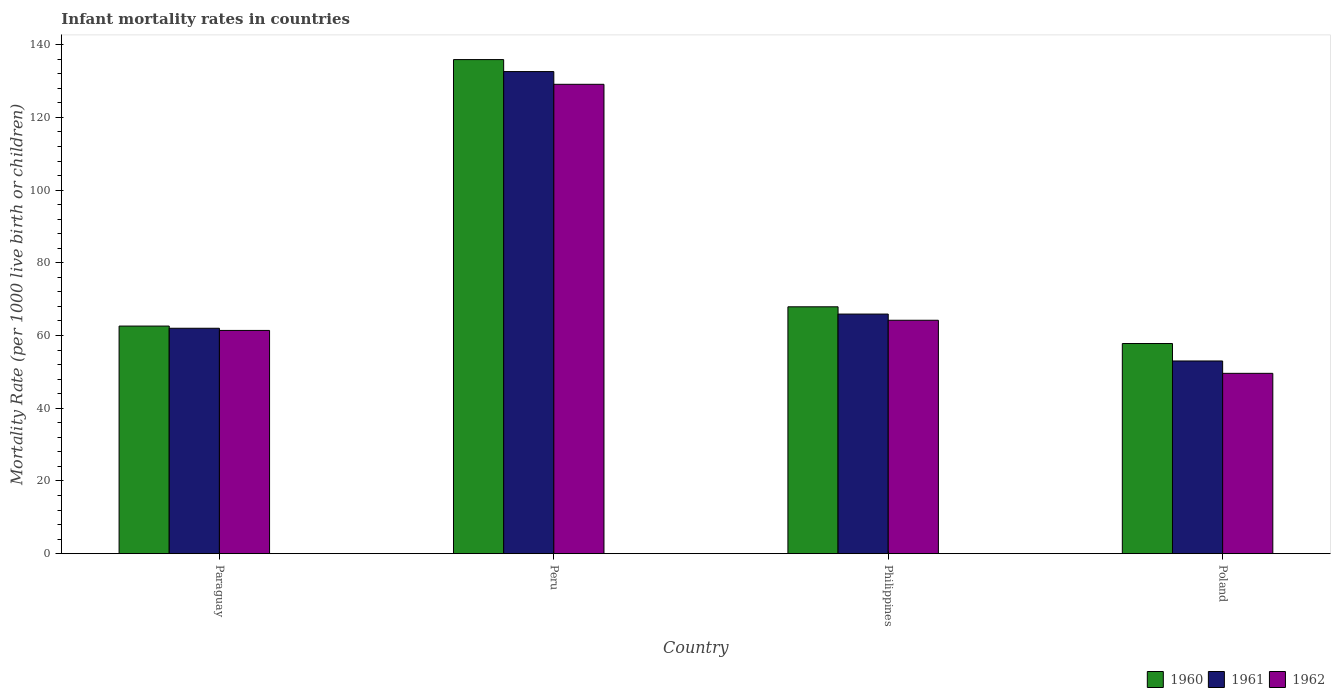How many bars are there on the 2nd tick from the left?
Give a very brief answer. 3. What is the label of the 1st group of bars from the left?
Your answer should be very brief. Paraguay. In how many cases, is the number of bars for a given country not equal to the number of legend labels?
Keep it short and to the point. 0. What is the infant mortality rate in 1961 in Poland?
Offer a terse response. 53. Across all countries, what is the maximum infant mortality rate in 1962?
Keep it short and to the point. 129.1. Across all countries, what is the minimum infant mortality rate in 1960?
Offer a terse response. 57.8. What is the total infant mortality rate in 1962 in the graph?
Your response must be concise. 304.3. What is the difference between the infant mortality rate in 1962 in Peru and the infant mortality rate in 1960 in Philippines?
Give a very brief answer. 61.2. What is the average infant mortality rate in 1962 per country?
Offer a very short reply. 76.08. What is the difference between the infant mortality rate of/in 1962 and infant mortality rate of/in 1961 in Peru?
Ensure brevity in your answer.  -3.5. What is the ratio of the infant mortality rate in 1960 in Peru to that in Philippines?
Make the answer very short. 2. Is the infant mortality rate in 1961 in Paraguay less than that in Poland?
Give a very brief answer. No. What is the difference between the highest and the second highest infant mortality rate in 1960?
Make the answer very short. 5.3. What is the difference between the highest and the lowest infant mortality rate in 1960?
Your answer should be very brief. 78.1. What does the 1st bar from the left in Poland represents?
Give a very brief answer. 1960. What does the 2nd bar from the right in Philippines represents?
Give a very brief answer. 1961. Is it the case that in every country, the sum of the infant mortality rate in 1962 and infant mortality rate in 1960 is greater than the infant mortality rate in 1961?
Offer a very short reply. Yes. How many bars are there?
Provide a short and direct response. 12. Are all the bars in the graph horizontal?
Give a very brief answer. No. What is the difference between two consecutive major ticks on the Y-axis?
Your response must be concise. 20. Does the graph contain any zero values?
Offer a terse response. No. How many legend labels are there?
Your response must be concise. 3. How are the legend labels stacked?
Provide a short and direct response. Horizontal. What is the title of the graph?
Offer a very short reply. Infant mortality rates in countries. Does "1984" appear as one of the legend labels in the graph?
Your answer should be very brief. No. What is the label or title of the X-axis?
Keep it short and to the point. Country. What is the label or title of the Y-axis?
Offer a terse response. Mortality Rate (per 1000 live birth or children). What is the Mortality Rate (per 1000 live birth or children) of 1960 in Paraguay?
Provide a short and direct response. 62.6. What is the Mortality Rate (per 1000 live birth or children) in 1961 in Paraguay?
Provide a succinct answer. 62. What is the Mortality Rate (per 1000 live birth or children) in 1962 in Paraguay?
Keep it short and to the point. 61.4. What is the Mortality Rate (per 1000 live birth or children) of 1960 in Peru?
Your response must be concise. 135.9. What is the Mortality Rate (per 1000 live birth or children) in 1961 in Peru?
Offer a very short reply. 132.6. What is the Mortality Rate (per 1000 live birth or children) in 1962 in Peru?
Provide a short and direct response. 129.1. What is the Mortality Rate (per 1000 live birth or children) of 1960 in Philippines?
Your answer should be very brief. 67.9. What is the Mortality Rate (per 1000 live birth or children) of 1961 in Philippines?
Make the answer very short. 65.9. What is the Mortality Rate (per 1000 live birth or children) of 1962 in Philippines?
Offer a very short reply. 64.2. What is the Mortality Rate (per 1000 live birth or children) of 1960 in Poland?
Your response must be concise. 57.8. What is the Mortality Rate (per 1000 live birth or children) in 1961 in Poland?
Provide a succinct answer. 53. What is the Mortality Rate (per 1000 live birth or children) of 1962 in Poland?
Your response must be concise. 49.6. Across all countries, what is the maximum Mortality Rate (per 1000 live birth or children) in 1960?
Your answer should be very brief. 135.9. Across all countries, what is the maximum Mortality Rate (per 1000 live birth or children) in 1961?
Offer a terse response. 132.6. Across all countries, what is the maximum Mortality Rate (per 1000 live birth or children) of 1962?
Your response must be concise. 129.1. Across all countries, what is the minimum Mortality Rate (per 1000 live birth or children) of 1960?
Provide a succinct answer. 57.8. Across all countries, what is the minimum Mortality Rate (per 1000 live birth or children) in 1961?
Your answer should be very brief. 53. Across all countries, what is the minimum Mortality Rate (per 1000 live birth or children) in 1962?
Offer a terse response. 49.6. What is the total Mortality Rate (per 1000 live birth or children) in 1960 in the graph?
Your answer should be very brief. 324.2. What is the total Mortality Rate (per 1000 live birth or children) of 1961 in the graph?
Ensure brevity in your answer.  313.5. What is the total Mortality Rate (per 1000 live birth or children) in 1962 in the graph?
Your response must be concise. 304.3. What is the difference between the Mortality Rate (per 1000 live birth or children) in 1960 in Paraguay and that in Peru?
Keep it short and to the point. -73.3. What is the difference between the Mortality Rate (per 1000 live birth or children) of 1961 in Paraguay and that in Peru?
Provide a succinct answer. -70.6. What is the difference between the Mortality Rate (per 1000 live birth or children) in 1962 in Paraguay and that in Peru?
Provide a succinct answer. -67.7. What is the difference between the Mortality Rate (per 1000 live birth or children) of 1961 in Paraguay and that in Philippines?
Give a very brief answer. -3.9. What is the difference between the Mortality Rate (per 1000 live birth or children) of 1962 in Paraguay and that in Philippines?
Your answer should be very brief. -2.8. What is the difference between the Mortality Rate (per 1000 live birth or children) in 1960 in Paraguay and that in Poland?
Ensure brevity in your answer.  4.8. What is the difference between the Mortality Rate (per 1000 live birth or children) in 1960 in Peru and that in Philippines?
Offer a terse response. 68. What is the difference between the Mortality Rate (per 1000 live birth or children) of 1961 in Peru and that in Philippines?
Your response must be concise. 66.7. What is the difference between the Mortality Rate (per 1000 live birth or children) of 1962 in Peru and that in Philippines?
Keep it short and to the point. 64.9. What is the difference between the Mortality Rate (per 1000 live birth or children) of 1960 in Peru and that in Poland?
Your answer should be very brief. 78.1. What is the difference between the Mortality Rate (per 1000 live birth or children) of 1961 in Peru and that in Poland?
Offer a terse response. 79.6. What is the difference between the Mortality Rate (per 1000 live birth or children) in 1962 in Peru and that in Poland?
Make the answer very short. 79.5. What is the difference between the Mortality Rate (per 1000 live birth or children) in 1961 in Philippines and that in Poland?
Keep it short and to the point. 12.9. What is the difference between the Mortality Rate (per 1000 live birth or children) in 1960 in Paraguay and the Mortality Rate (per 1000 live birth or children) in 1961 in Peru?
Make the answer very short. -70. What is the difference between the Mortality Rate (per 1000 live birth or children) of 1960 in Paraguay and the Mortality Rate (per 1000 live birth or children) of 1962 in Peru?
Keep it short and to the point. -66.5. What is the difference between the Mortality Rate (per 1000 live birth or children) of 1961 in Paraguay and the Mortality Rate (per 1000 live birth or children) of 1962 in Peru?
Make the answer very short. -67.1. What is the difference between the Mortality Rate (per 1000 live birth or children) of 1960 in Paraguay and the Mortality Rate (per 1000 live birth or children) of 1962 in Philippines?
Give a very brief answer. -1.6. What is the difference between the Mortality Rate (per 1000 live birth or children) of 1960 in Paraguay and the Mortality Rate (per 1000 live birth or children) of 1961 in Poland?
Give a very brief answer. 9.6. What is the difference between the Mortality Rate (per 1000 live birth or children) in 1960 in Peru and the Mortality Rate (per 1000 live birth or children) in 1961 in Philippines?
Provide a succinct answer. 70. What is the difference between the Mortality Rate (per 1000 live birth or children) of 1960 in Peru and the Mortality Rate (per 1000 live birth or children) of 1962 in Philippines?
Your answer should be compact. 71.7. What is the difference between the Mortality Rate (per 1000 live birth or children) of 1961 in Peru and the Mortality Rate (per 1000 live birth or children) of 1962 in Philippines?
Your response must be concise. 68.4. What is the difference between the Mortality Rate (per 1000 live birth or children) in 1960 in Peru and the Mortality Rate (per 1000 live birth or children) in 1961 in Poland?
Your answer should be compact. 82.9. What is the difference between the Mortality Rate (per 1000 live birth or children) of 1960 in Peru and the Mortality Rate (per 1000 live birth or children) of 1962 in Poland?
Provide a succinct answer. 86.3. What is the difference between the Mortality Rate (per 1000 live birth or children) of 1960 in Philippines and the Mortality Rate (per 1000 live birth or children) of 1962 in Poland?
Provide a succinct answer. 18.3. What is the difference between the Mortality Rate (per 1000 live birth or children) of 1961 in Philippines and the Mortality Rate (per 1000 live birth or children) of 1962 in Poland?
Your answer should be compact. 16.3. What is the average Mortality Rate (per 1000 live birth or children) of 1960 per country?
Provide a succinct answer. 81.05. What is the average Mortality Rate (per 1000 live birth or children) in 1961 per country?
Ensure brevity in your answer.  78.38. What is the average Mortality Rate (per 1000 live birth or children) in 1962 per country?
Provide a succinct answer. 76.08. What is the difference between the Mortality Rate (per 1000 live birth or children) in 1960 and Mortality Rate (per 1000 live birth or children) in 1962 in Paraguay?
Offer a terse response. 1.2. What is the difference between the Mortality Rate (per 1000 live birth or children) of 1961 and Mortality Rate (per 1000 live birth or children) of 1962 in Peru?
Offer a terse response. 3.5. What is the difference between the Mortality Rate (per 1000 live birth or children) in 1960 and Mortality Rate (per 1000 live birth or children) in 1961 in Philippines?
Provide a short and direct response. 2. What is the difference between the Mortality Rate (per 1000 live birth or children) of 1961 and Mortality Rate (per 1000 live birth or children) of 1962 in Philippines?
Your response must be concise. 1.7. What is the difference between the Mortality Rate (per 1000 live birth or children) of 1960 and Mortality Rate (per 1000 live birth or children) of 1961 in Poland?
Make the answer very short. 4.8. What is the ratio of the Mortality Rate (per 1000 live birth or children) of 1960 in Paraguay to that in Peru?
Provide a short and direct response. 0.46. What is the ratio of the Mortality Rate (per 1000 live birth or children) of 1961 in Paraguay to that in Peru?
Keep it short and to the point. 0.47. What is the ratio of the Mortality Rate (per 1000 live birth or children) in 1962 in Paraguay to that in Peru?
Ensure brevity in your answer.  0.48. What is the ratio of the Mortality Rate (per 1000 live birth or children) in 1960 in Paraguay to that in Philippines?
Provide a succinct answer. 0.92. What is the ratio of the Mortality Rate (per 1000 live birth or children) in 1961 in Paraguay to that in Philippines?
Give a very brief answer. 0.94. What is the ratio of the Mortality Rate (per 1000 live birth or children) of 1962 in Paraguay to that in Philippines?
Offer a terse response. 0.96. What is the ratio of the Mortality Rate (per 1000 live birth or children) of 1960 in Paraguay to that in Poland?
Your response must be concise. 1.08. What is the ratio of the Mortality Rate (per 1000 live birth or children) of 1961 in Paraguay to that in Poland?
Offer a very short reply. 1.17. What is the ratio of the Mortality Rate (per 1000 live birth or children) of 1962 in Paraguay to that in Poland?
Provide a short and direct response. 1.24. What is the ratio of the Mortality Rate (per 1000 live birth or children) of 1960 in Peru to that in Philippines?
Give a very brief answer. 2. What is the ratio of the Mortality Rate (per 1000 live birth or children) in 1961 in Peru to that in Philippines?
Provide a short and direct response. 2.01. What is the ratio of the Mortality Rate (per 1000 live birth or children) in 1962 in Peru to that in Philippines?
Provide a succinct answer. 2.01. What is the ratio of the Mortality Rate (per 1000 live birth or children) in 1960 in Peru to that in Poland?
Offer a terse response. 2.35. What is the ratio of the Mortality Rate (per 1000 live birth or children) in 1961 in Peru to that in Poland?
Give a very brief answer. 2.5. What is the ratio of the Mortality Rate (per 1000 live birth or children) of 1962 in Peru to that in Poland?
Give a very brief answer. 2.6. What is the ratio of the Mortality Rate (per 1000 live birth or children) of 1960 in Philippines to that in Poland?
Your response must be concise. 1.17. What is the ratio of the Mortality Rate (per 1000 live birth or children) of 1961 in Philippines to that in Poland?
Offer a terse response. 1.24. What is the ratio of the Mortality Rate (per 1000 live birth or children) of 1962 in Philippines to that in Poland?
Provide a succinct answer. 1.29. What is the difference between the highest and the second highest Mortality Rate (per 1000 live birth or children) of 1960?
Your answer should be very brief. 68. What is the difference between the highest and the second highest Mortality Rate (per 1000 live birth or children) in 1961?
Offer a very short reply. 66.7. What is the difference between the highest and the second highest Mortality Rate (per 1000 live birth or children) in 1962?
Offer a very short reply. 64.9. What is the difference between the highest and the lowest Mortality Rate (per 1000 live birth or children) of 1960?
Your answer should be compact. 78.1. What is the difference between the highest and the lowest Mortality Rate (per 1000 live birth or children) of 1961?
Your response must be concise. 79.6. What is the difference between the highest and the lowest Mortality Rate (per 1000 live birth or children) in 1962?
Your response must be concise. 79.5. 